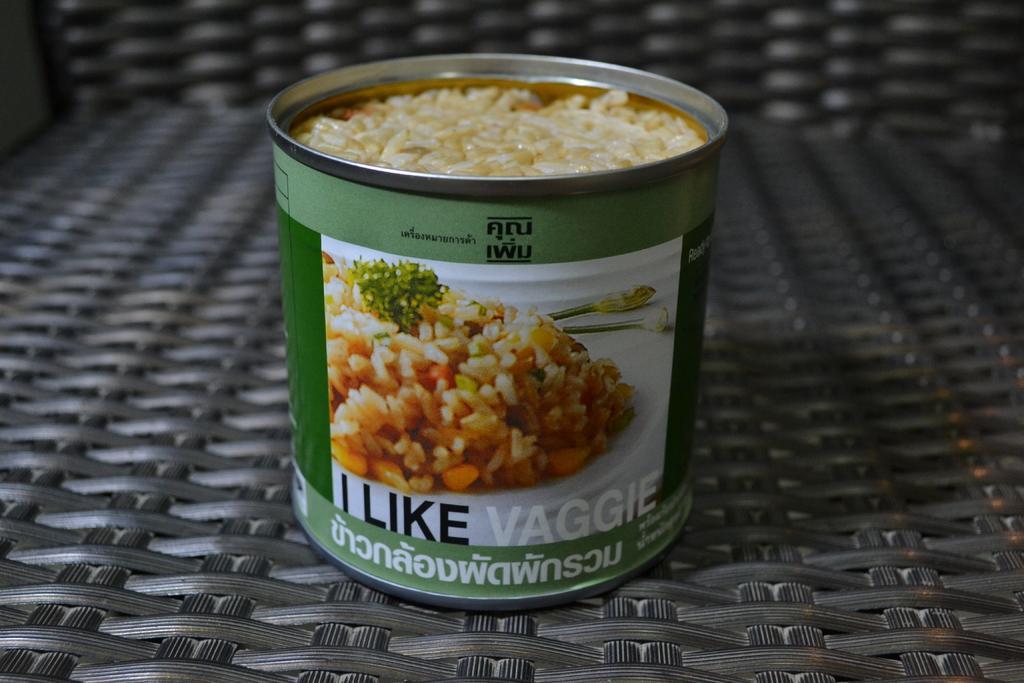Can you describe this image briefly? This picture shows a box with some food in it on the chair. 